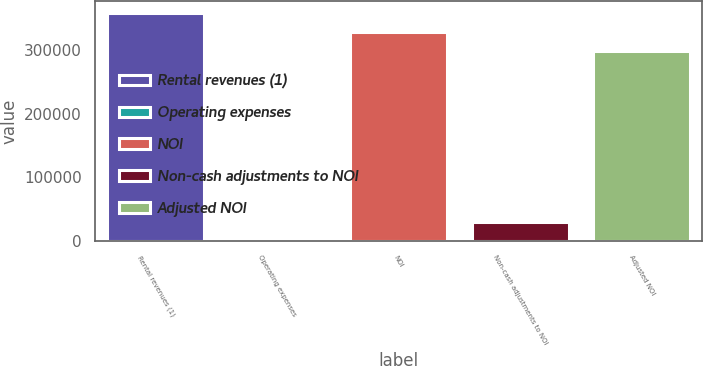Convert chart. <chart><loc_0><loc_0><loc_500><loc_500><bar_chart><fcel>Rental revenues (1)<fcel>Operating expenses<fcel>NOI<fcel>Non-cash adjustments to NOI<fcel>Adjusted NOI<nl><fcel>358005<fcel>237<fcel>327731<fcel>30510.9<fcel>297457<nl></chart> 